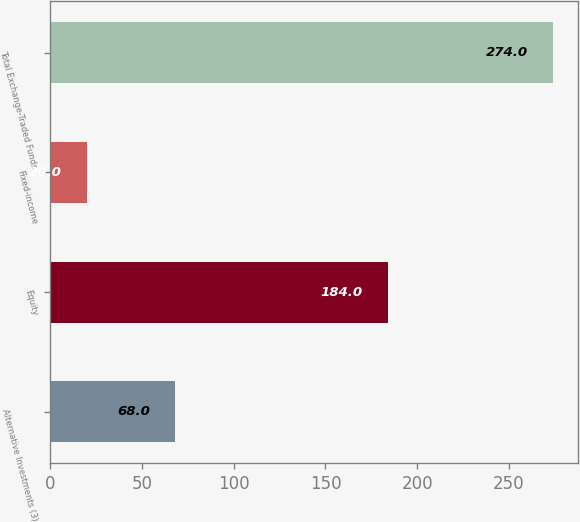Convert chart. <chart><loc_0><loc_0><loc_500><loc_500><bar_chart><fcel>Alternative Investments (3)<fcel>Equity<fcel>Fixed-income<fcel>Total Exchange-Traded Funds<nl><fcel>68<fcel>184<fcel>20<fcel>274<nl></chart> 